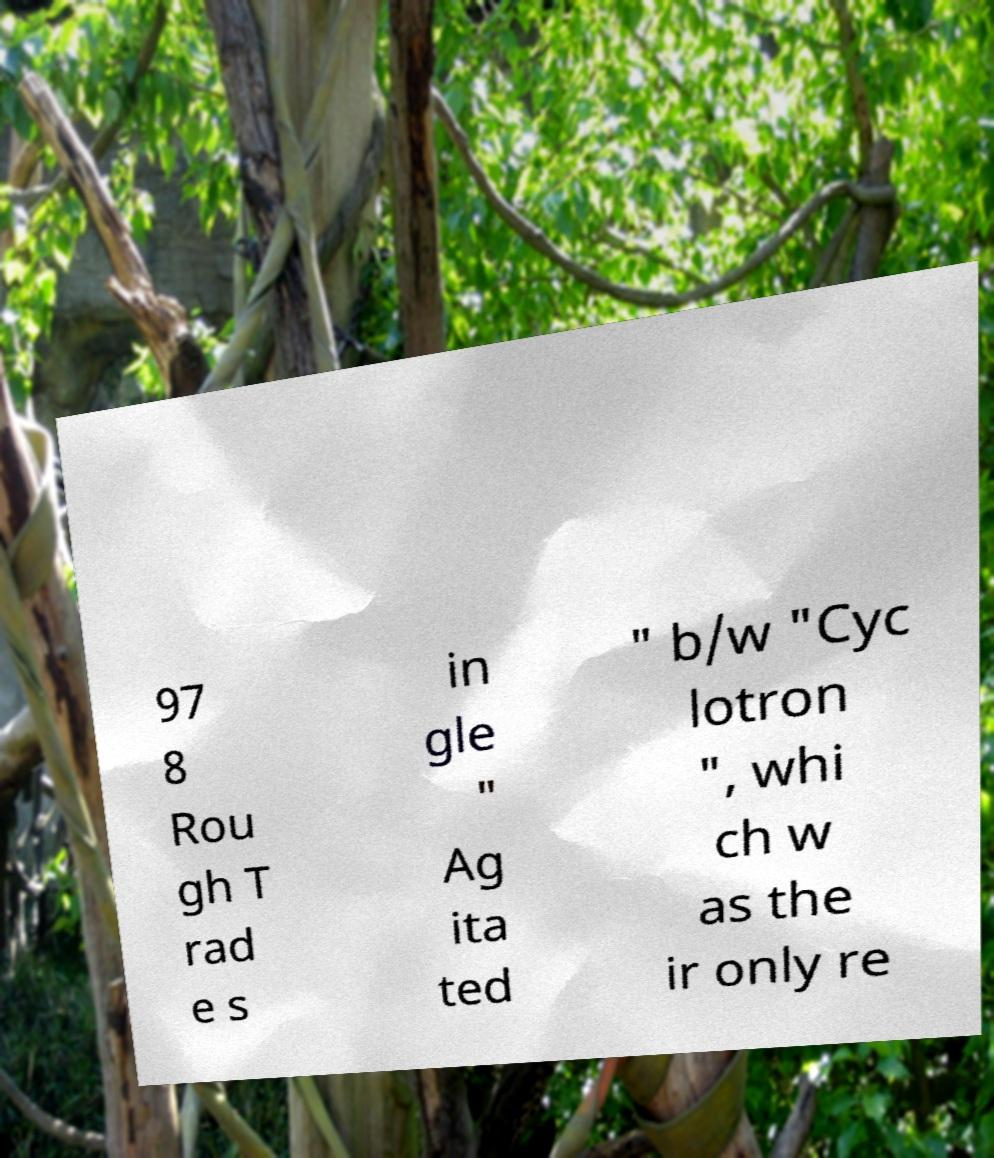Could you extract and type out the text from this image? 97 8 Rou gh T rad e s in gle " Ag ita ted " b/w "Cyc lotron ", whi ch w as the ir only re 